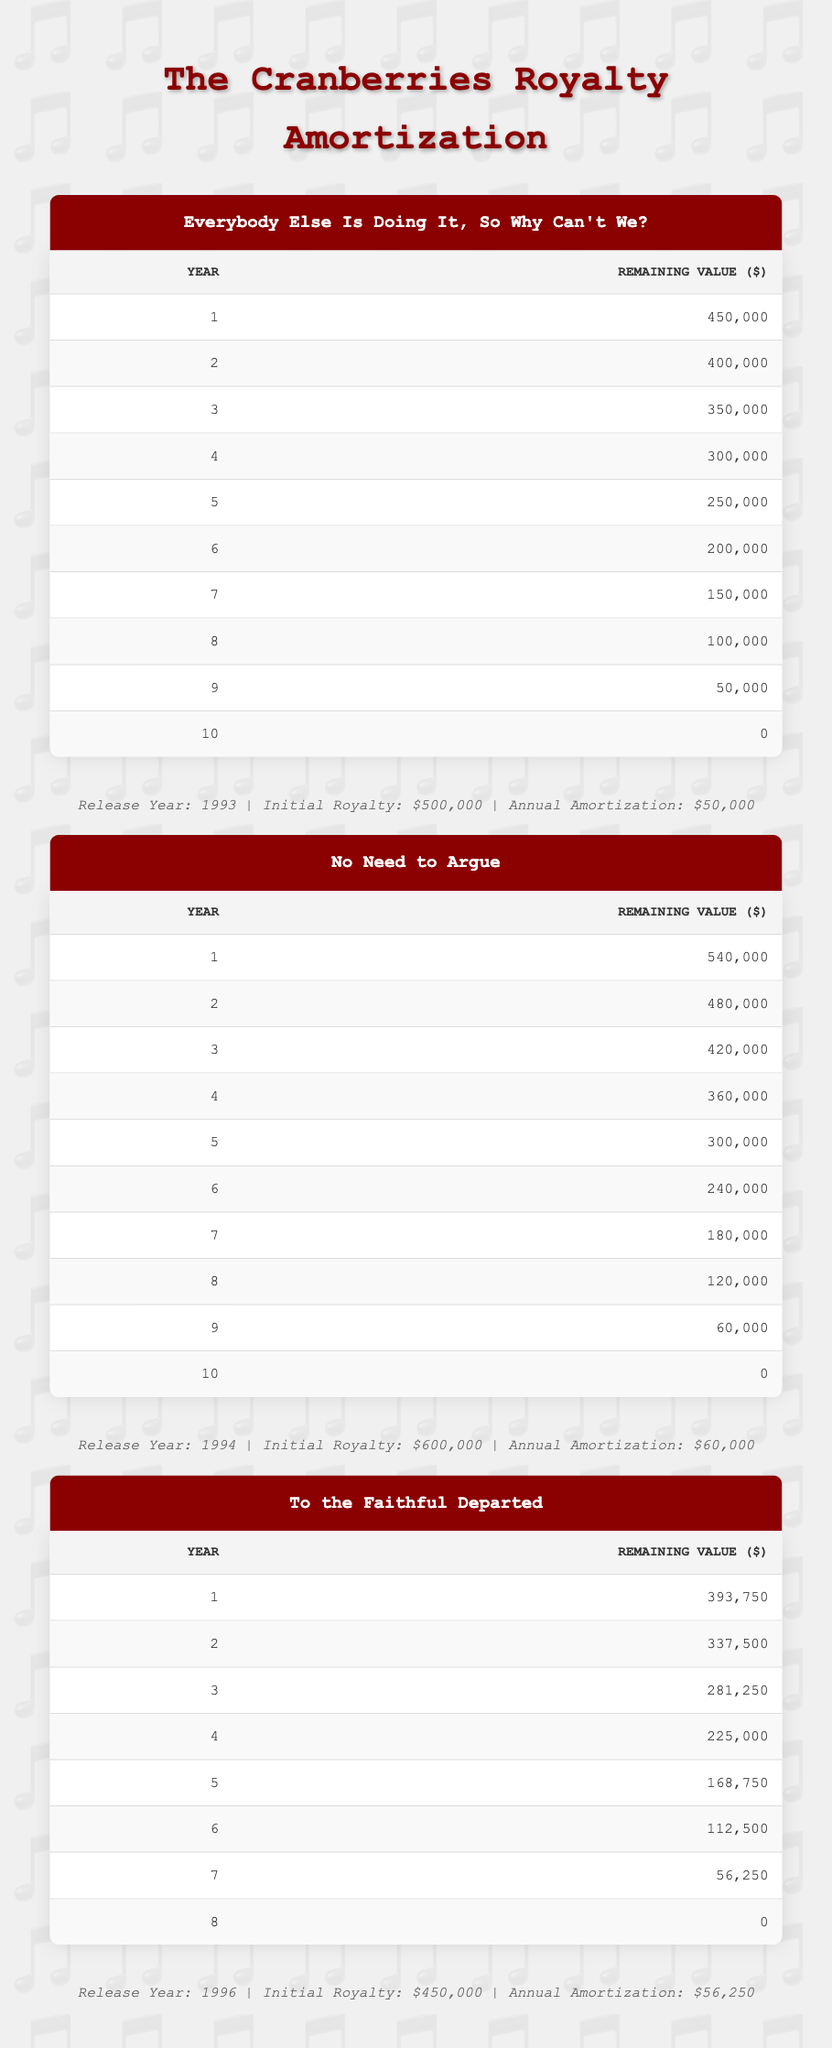What is the initial royalty amount for "No Need to Argue"? The table explicitly states the initial royalty amount for "No Need to Argue" as $600,000 in the album information section.
Answer: 600,000 What is the remaining value after the 5th year for "To the Faithful Departed"? According to the table, the remaining value after the 5th year for "To the Faithful Departed" is listed as $168,750 in the remaining value section.
Answer: 168,750 Is the annual amortization for "Everybody Else Is Doing It, So Why Can't We?" greater than $50,000? The table shows the annual amortization for this album as $50,000, so it is not greater than $50,000.
Answer: No What is the total initial royalty amount for all three albums combined? The total initial royalty amount is calculated by adding the initial royalties of all three albums: $500,000 + $600,000 + $450,000 = $1,550,000.
Answer: 1,550,000 What is the remaining value for "No Need to Argue" in year 7? The remaining value for "No Need to Argue" in year 7 is provided in the table as $180,000 in the corresponding remaining value section.
Answer: 180,000 Which album had the highest annual amortization? By comparing the annual amortization values for each album, "No Need to Argue" has the highest value at $60,000.
Answer: No Need to Argue How much does the value decrease from year 9 to year 10 for "Everybody Else Is Doing It, So Why Can't We?" The table shows the remaining values as $50,000 in year 9 and $0 in year 10. The decrease is calculated as $50,000 - $0 = $50,000.
Answer: 50,000 What is the average remaining value for the first three years of "To the Faithful Departed"? The remaining values for the first three years are $393,750 (Year 1), $337,500 (Year 2), and $281,250 (Year 3). The average is calculated as (393,750 + 337,500 + 281,250) / 3 = $336,667.
Answer: 336,667 Which album completely amortizes its value first? By analyzing the amortization periods, "To the Faithful Departed" completely amortizes in 8 years, which is the shortest period among the three albums.
Answer: To the Faithful Departed 